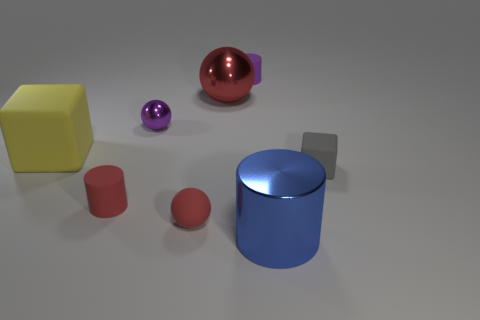The purple object that is made of the same material as the tiny gray thing is what size?
Give a very brief answer. Small. Are there fewer metal cylinders than big gray matte cubes?
Provide a succinct answer. No. What material is the thing that is left of the small rubber cylinder on the left side of the tiny matte thing behind the gray matte cube made of?
Provide a short and direct response. Rubber. Is the material of the red thing to the left of the tiny rubber ball the same as the small purple object on the right side of the large red ball?
Your response must be concise. Yes. What size is the object that is both behind the tiny shiny sphere and in front of the purple rubber thing?
Provide a succinct answer. Large. There is a yellow block that is the same size as the red metal ball; what material is it?
Provide a succinct answer. Rubber. There is a tiny red matte object that is in front of the rubber cylinder that is to the left of the tiny purple matte thing; what number of big objects are right of it?
Offer a very short reply. 2. There is a tiny metal ball that is to the right of the yellow matte thing; is it the same color as the rubber object on the right side of the blue cylinder?
Your answer should be compact. No. The thing that is on the right side of the red metal ball and behind the tiny purple ball is what color?
Provide a short and direct response. Purple. How many red matte cylinders have the same size as the metal cylinder?
Your answer should be very brief. 0. 